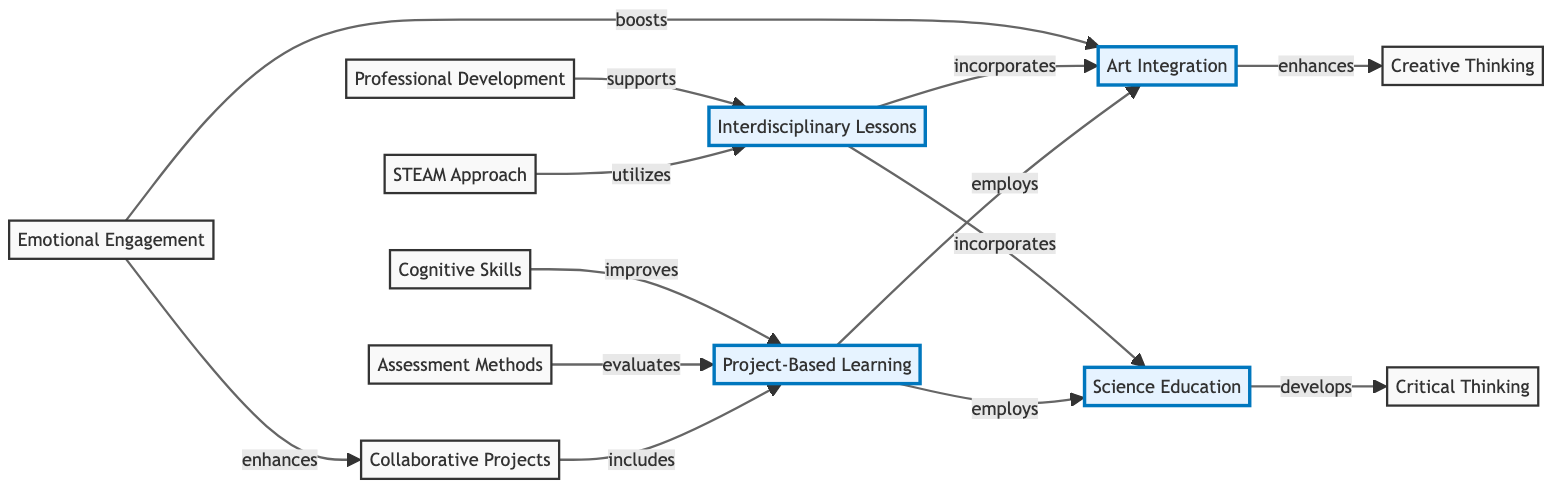What are the two primary fields integrated in this concept map? The concept map primarily integrates "Art Integration" and "Science Education," as they are the central nodes connected to various strategies and outcomes.
Answer: Art Integration, Science Education What relationship does Project-Based Learning have with Science Education? The diagram indicates that Project-Based Learning employs Science Education, showing the connection and necessary integration for effective educational strategies.
Answer: employs How many nodes are present in the diagram? By counting all the distinct items within the nodes section, we find there are a total of eleven nodes represented in the diagram.
Answer: 11 Which strategy enhances Creative Thinking? The diagram specifies that "Art Integration" enhances "Creative Thinking," establishing a direct connection between these educational concepts.
Answer: enhances What does the STEAM Approach utilize? The concept map clearly states that the STEAM Approach utilizes Interdisciplinary Lessons, indicating the effective strategy for art and science integration.
Answer: Interdisciplinary Lessons What role does Emotional Engagement play in relation to Art Integration? The diagram illustrates that Emotional Engagement boosts Art Integration, highlighting its importance in enhancing artistic educational strategies.
Answer: boosts Which strategy is evaluated by Assessment Methods? The diagram indicates that Assessment Methods evaluates Project-Based Learning, showing how effectiveness is assessed in this pedagogical approach.
Answer: Project-Based Learning How do Collaborative Projects relate to Project-Based Learning? According to the diagram, Collaborative Projects include Project-Based Learning, showing their interconnectedness in teaching strategies.
Answer: includes Which element supports Interdisciplinary Lessons? The map identifies Professional Development as the supporting element for Interdisciplinary Lessons, indicating its importance for successful integration.
Answer: supports 